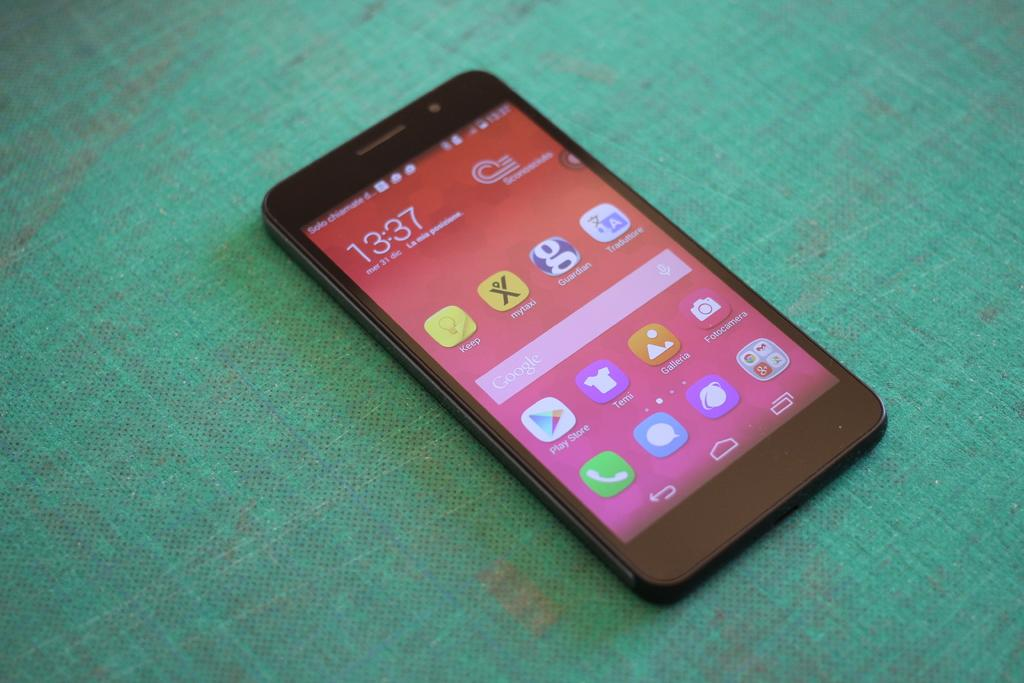<image>
Provide a brief description of the given image. A smartphone with a red background and the time reads 13:37. 